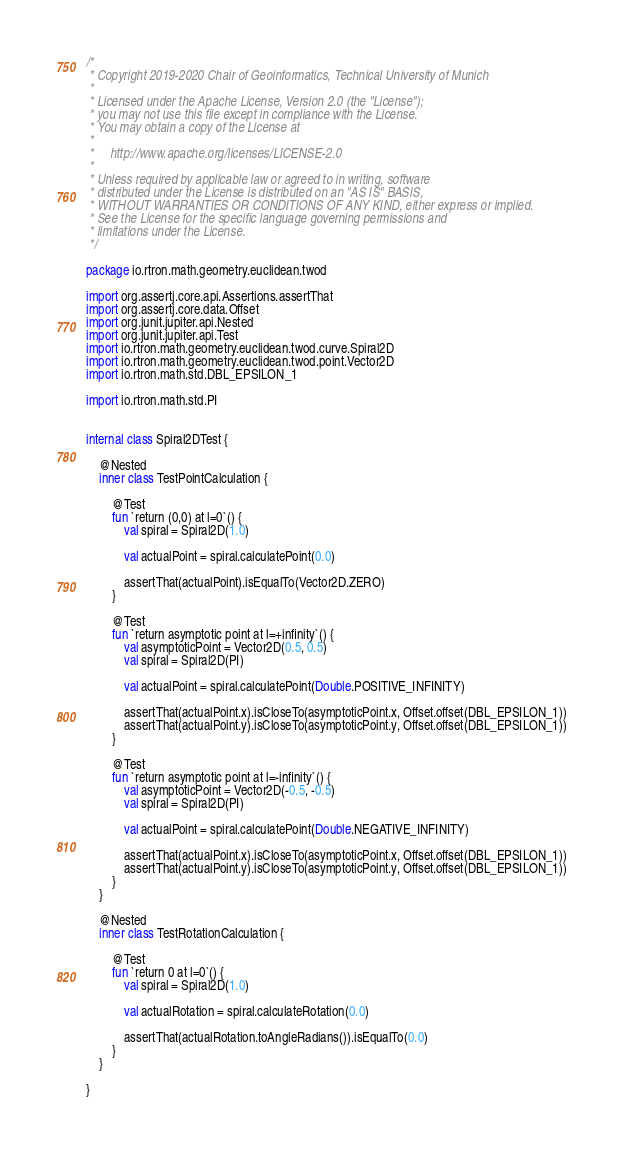<code> <loc_0><loc_0><loc_500><loc_500><_Kotlin_>/*
 * Copyright 2019-2020 Chair of Geoinformatics, Technical University of Munich
 *
 * Licensed under the Apache License, Version 2.0 (the "License");
 * you may not use this file except in compliance with the License.
 * You may obtain a copy of the License at
 *
 *     http://www.apache.org/licenses/LICENSE-2.0
 *
 * Unless required by applicable law or agreed to in writing, software
 * distributed under the License is distributed on an "AS IS" BASIS,
 * WITHOUT WARRANTIES OR CONDITIONS OF ANY KIND, either express or implied.
 * See the License for the specific language governing permissions and
 * limitations under the License.
 */

package io.rtron.math.geometry.euclidean.twod

import org.assertj.core.api.Assertions.assertThat
import org.assertj.core.data.Offset
import org.junit.jupiter.api.Nested
import org.junit.jupiter.api.Test
import io.rtron.math.geometry.euclidean.twod.curve.Spiral2D
import io.rtron.math.geometry.euclidean.twod.point.Vector2D
import io.rtron.math.std.DBL_EPSILON_1

import io.rtron.math.std.PI


internal class Spiral2DTest {

    @Nested
    inner class TestPointCalculation {

        @Test
        fun `return (0,0) at l=0`() {
            val spiral = Spiral2D(1.0)

            val actualPoint = spiral.calculatePoint(0.0)

            assertThat(actualPoint).isEqualTo(Vector2D.ZERO)
        }

        @Test
        fun `return asymptotic point at l=+infinity`() {
            val asymptoticPoint = Vector2D(0.5, 0.5)
            val spiral = Spiral2D(PI)

            val actualPoint = spiral.calculatePoint(Double.POSITIVE_INFINITY)

            assertThat(actualPoint.x).isCloseTo(asymptoticPoint.x, Offset.offset(DBL_EPSILON_1))
            assertThat(actualPoint.y).isCloseTo(asymptoticPoint.y, Offset.offset(DBL_EPSILON_1))
        }

        @Test
        fun `return asymptotic point at l=-infinity`() {
            val asymptoticPoint = Vector2D(-0.5, -0.5)
            val spiral = Spiral2D(PI)

            val actualPoint = spiral.calculatePoint(Double.NEGATIVE_INFINITY)

            assertThat(actualPoint.x).isCloseTo(asymptoticPoint.x, Offset.offset(DBL_EPSILON_1))
            assertThat(actualPoint.y).isCloseTo(asymptoticPoint.y, Offset.offset(DBL_EPSILON_1))
        }
    }

    @Nested
    inner class TestRotationCalculation {

        @Test
        fun `return 0 at l=0`() {
            val spiral = Spiral2D(1.0)

            val actualRotation = spiral.calculateRotation(0.0)

            assertThat(actualRotation.toAngleRadians()).isEqualTo(0.0)
        }
    }

}
</code> 